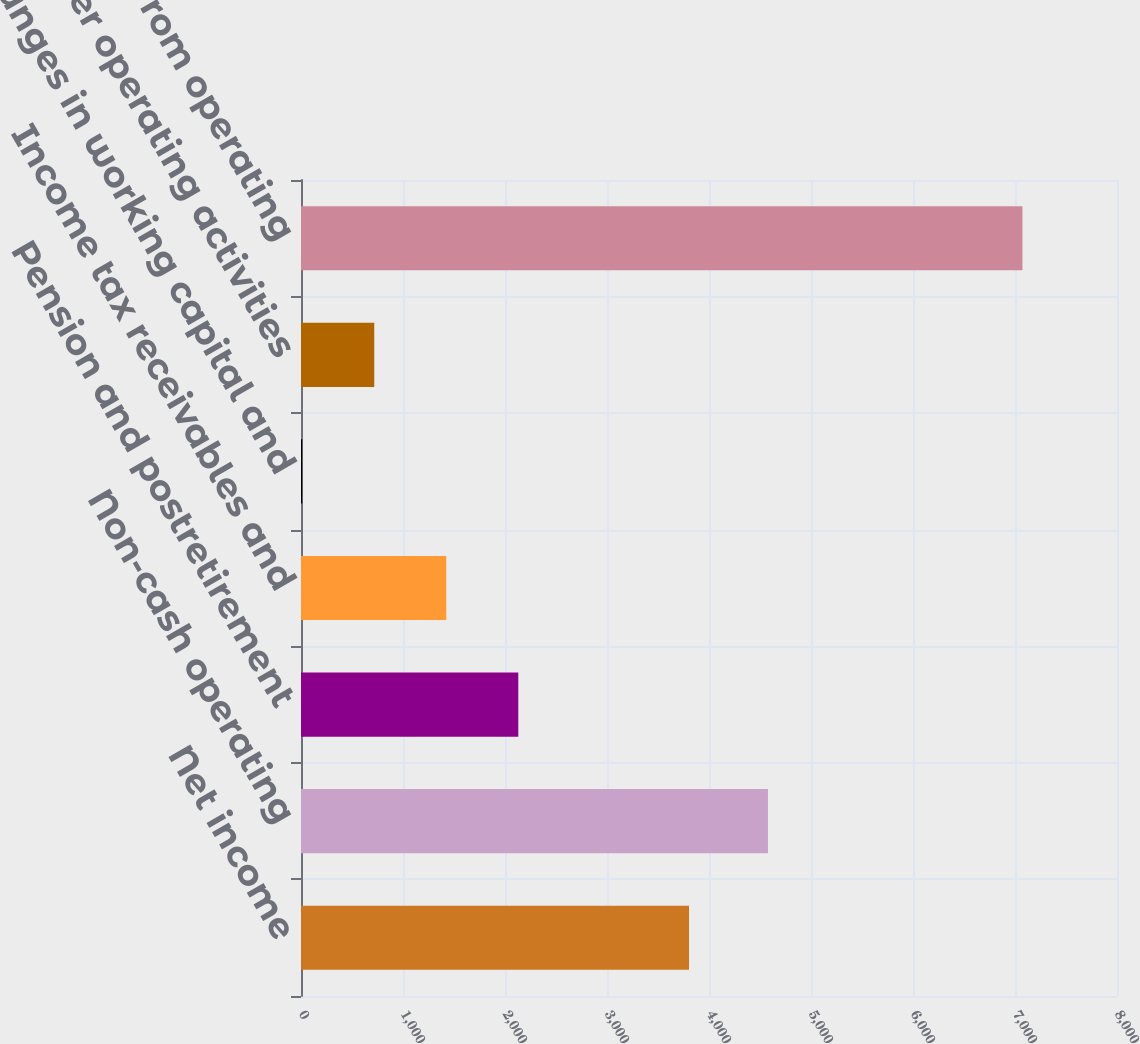<chart> <loc_0><loc_0><loc_500><loc_500><bar_chart><fcel>Net income<fcel>Non-cash operating<fcel>Pension and postretirement<fcel>Income tax receivables and<fcel>Changes in working capital and<fcel>Other operating activities<fcel>Net cash from operating<nl><fcel>3804<fcel>4578<fcel>2130.3<fcel>1424.2<fcel>12<fcel>718.1<fcel>7073<nl></chart> 